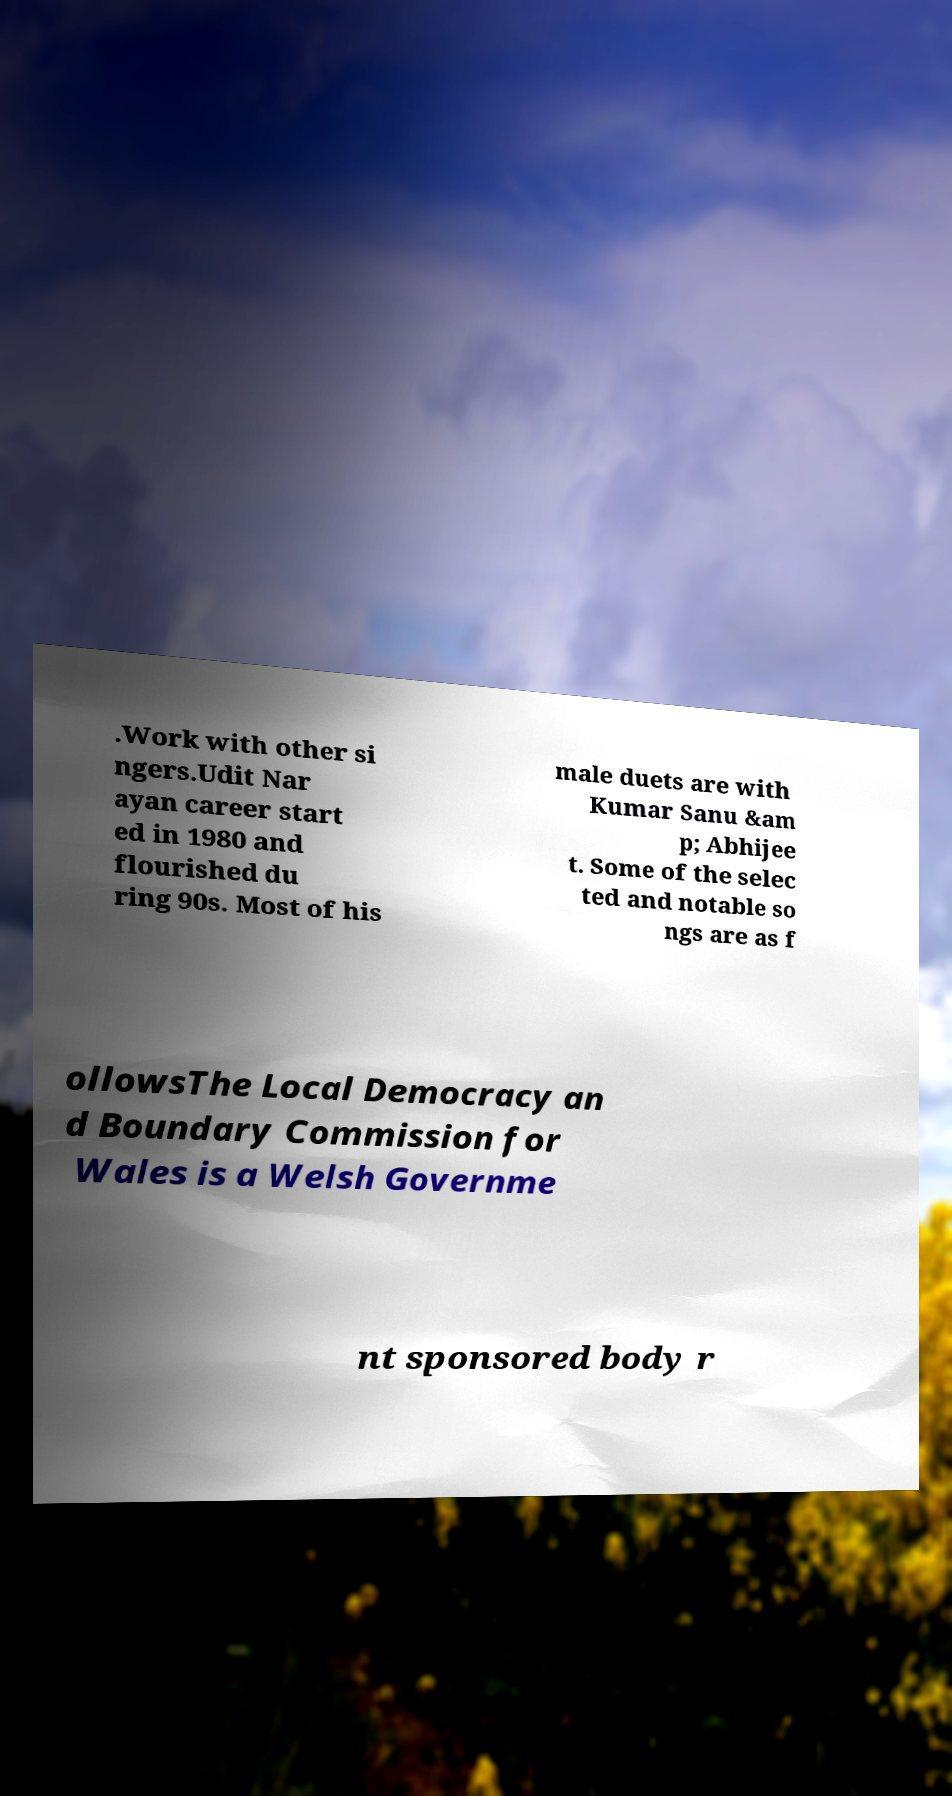Can you read and provide the text displayed in the image?This photo seems to have some interesting text. Can you extract and type it out for me? .Work with other si ngers.Udit Nar ayan career start ed in 1980 and flourished du ring 90s. Most of his male duets are with Kumar Sanu &am p; Abhijee t. Some of the selec ted and notable so ngs are as f ollowsThe Local Democracy an d Boundary Commission for Wales is a Welsh Governme nt sponsored body r 